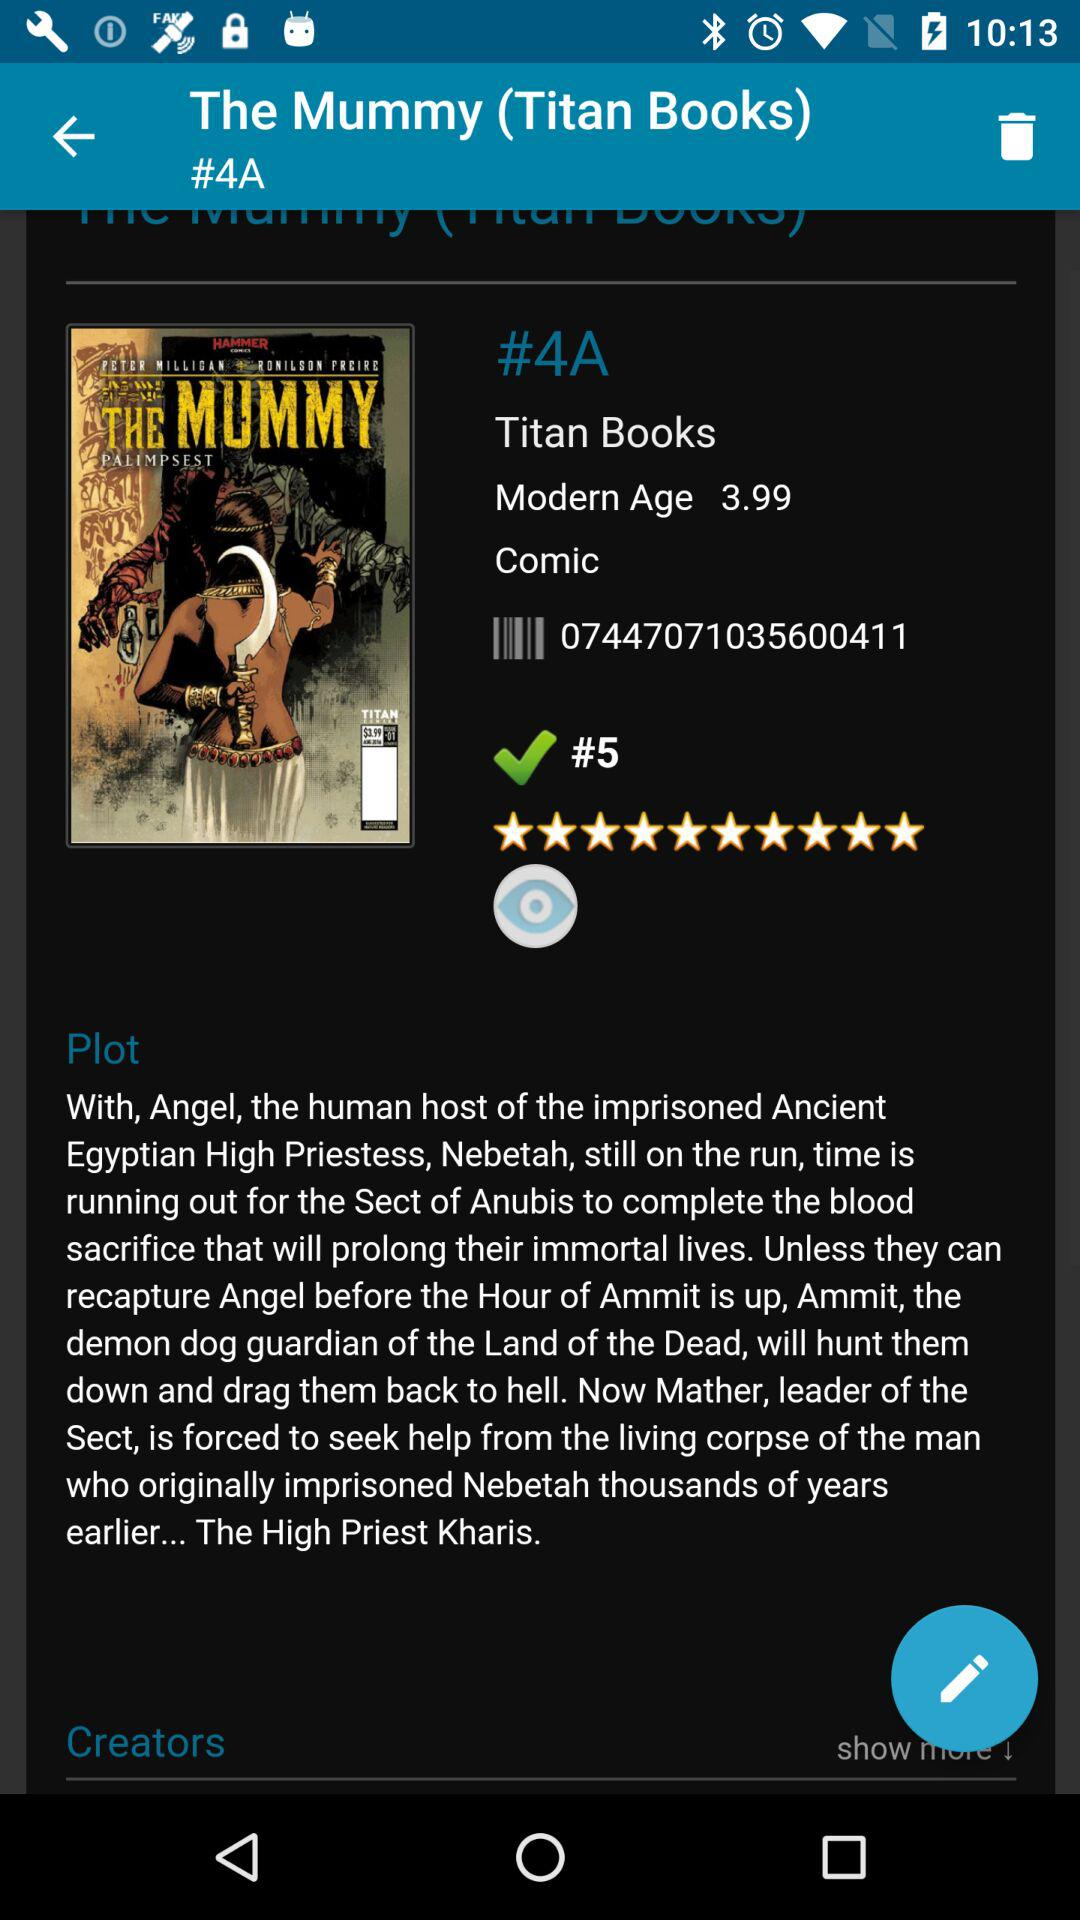What is the genre of the movie? The genre of the movie is comic. 